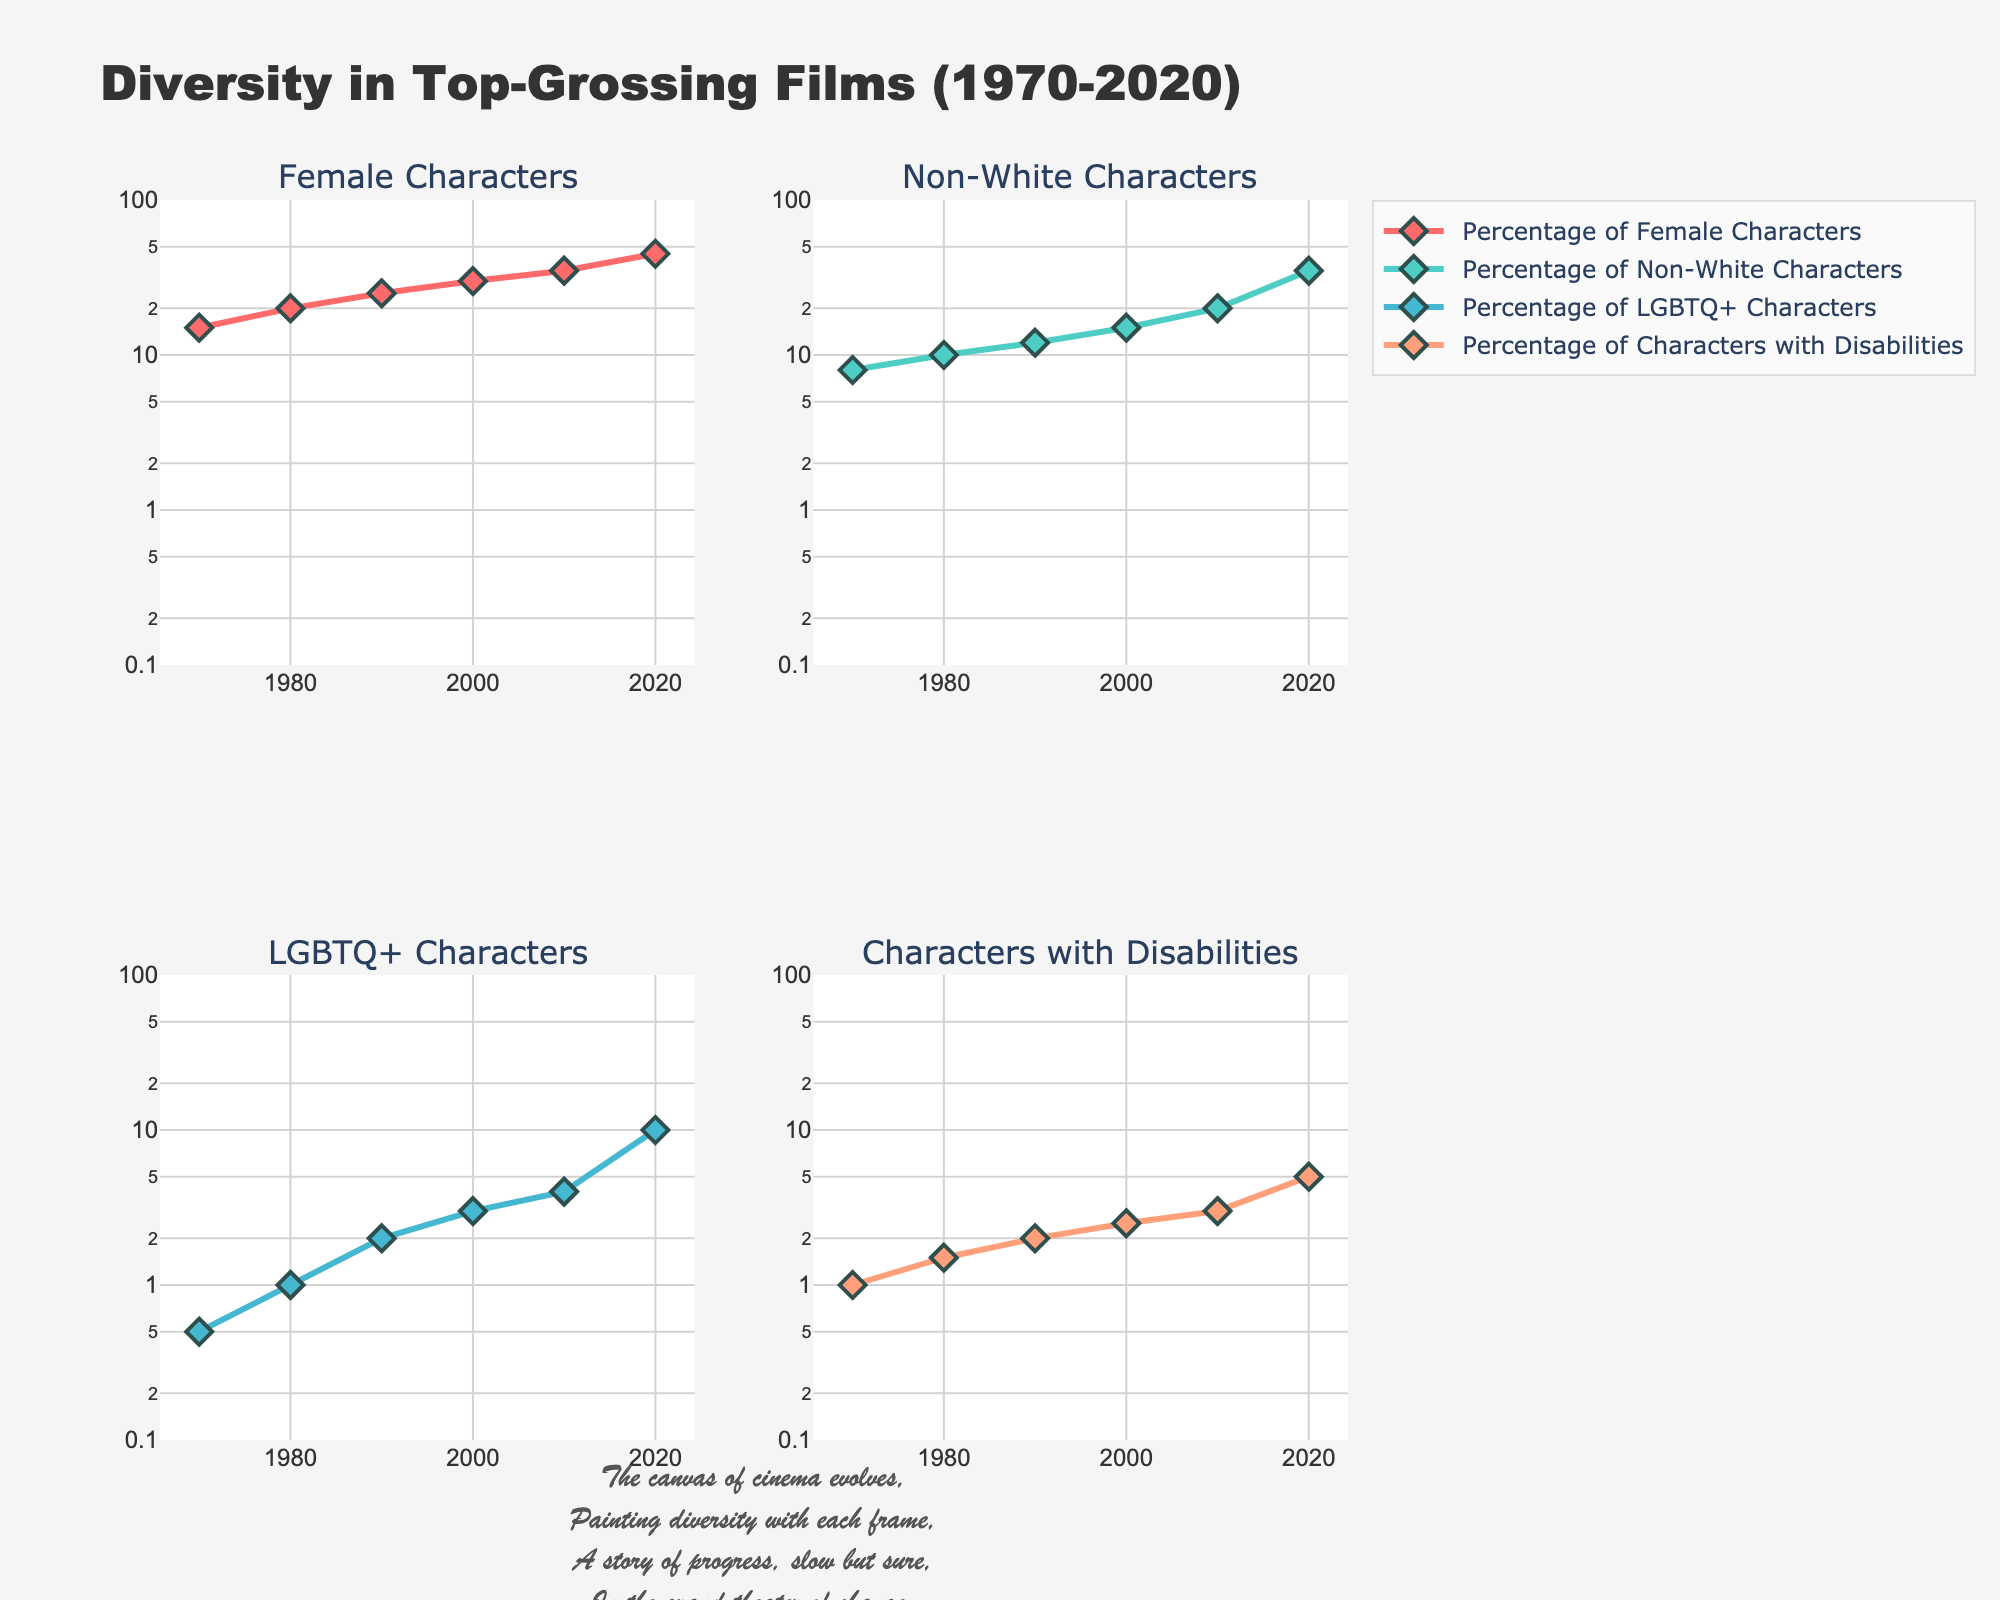What's the title of the figure? The title of the figure is located at the top center. It reads "Diversity in Top-Grossing Films (1970-2020)" in bold text.
Answer: Diversity in Top-Grossing Films (1970-2020) How does the percentage of female characters change from 1970 to 2020? To find this, refer to the subplot titled "Female Characters". The percentage starts at 15% in 1970 and increases to 45% in 2020.
Answer: It increases from 15% to 45% Which subplot shows the largest increase in diversity over the years? To determine this, compare the increase in percentages for all subplots from 1970 to 2020. The "Percentage of Non-White Characters" subplot shows an increase from 8% to 35%, which is the largest increase.
Answer: Non-White Characters How many more percentage points of non-white characters were there in 2020 compared to 1980? To find the additional percentage points, subtract the 1980 value from the 2020 value in the "Non-White Characters" subplot. 35% (2020) - 10% (1980) = 25%.
Answer: 25% What is the trend for the percentage of characters with disabilities from 1990 to 2020? Analyze the "Characters with Disabilities" subplot. The percentage rises from 2% in 1990 to 5% in 2020, showing a steady increase.
Answer: Steady increase Which category saw the smallest representation percentage-wise in 1970? By checking the subplots for the values in 1970, "LGBTQ+ Characters" had the smallest representation, starting at 0.5%.
Answer: LGBTQ+ Characters Among the four categories, which had the highest percentage representation in 2020? Check the values in each subplot for 2020. "Female Characters" had the highest representation at 45%.
Answer: Female Characters How does the percentage of LGBTQ+ characters compare between 1980 and 1990? In the "LGBTQ+ Characters" subplot, the percentage increases from 1% in 1980 to 2% in 1990, which means it doubled.
Answer: It doubled What mathematical function is applied to the y-axes? By looking at the y-axes of all subplots, it's apparent they are scaled logarithmically.
Answer: Logarithmic Calculate the average percentage of female characters from 1970 to 2020. To find the average, sum the percentages of female characters from each year and divide by the number of years: (15 + 20 + 25 + 30 + 35 + 45) / 6 = 170 / 6 ≈ 28.33%.
Answer: 28.33% 